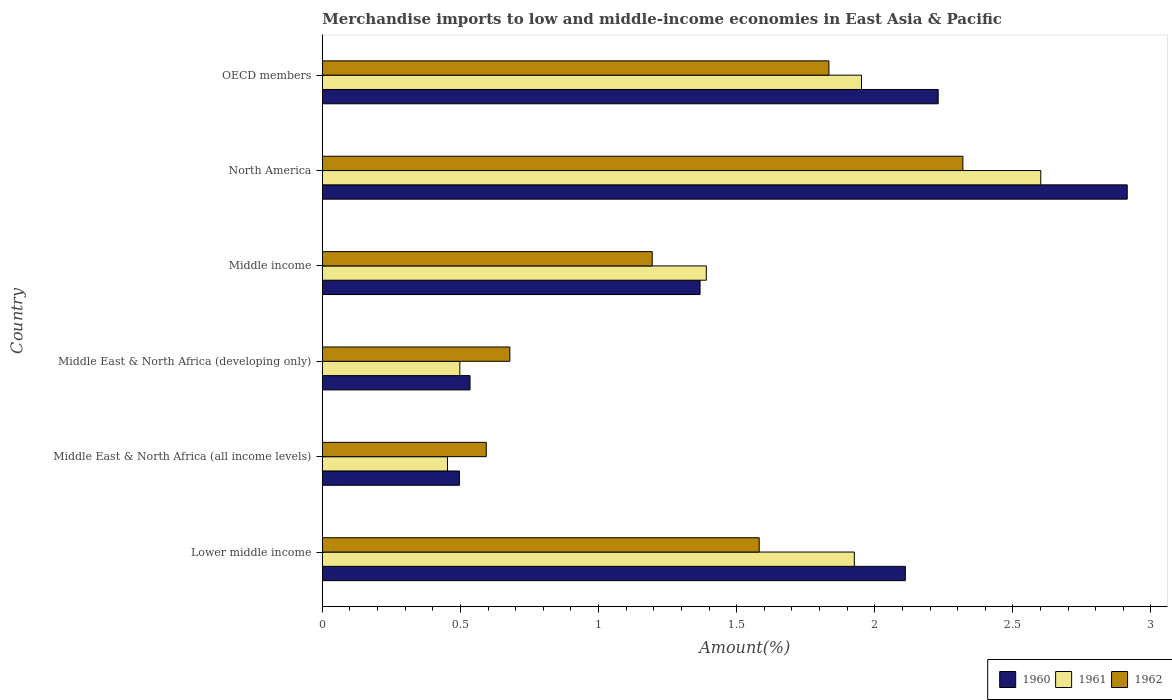How many different coloured bars are there?
Give a very brief answer. 3. How many groups of bars are there?
Your answer should be compact. 6. How many bars are there on the 3rd tick from the top?
Make the answer very short. 3. How many bars are there on the 5th tick from the bottom?
Keep it short and to the point. 3. What is the label of the 4th group of bars from the top?
Your answer should be compact. Middle East & North Africa (developing only). What is the percentage of amount earned from merchandise imports in 1962 in North America?
Provide a short and direct response. 2.32. Across all countries, what is the maximum percentage of amount earned from merchandise imports in 1962?
Provide a succinct answer. 2.32. Across all countries, what is the minimum percentage of amount earned from merchandise imports in 1962?
Offer a terse response. 0.59. In which country was the percentage of amount earned from merchandise imports in 1961 minimum?
Your answer should be compact. Middle East & North Africa (all income levels). What is the total percentage of amount earned from merchandise imports in 1962 in the graph?
Offer a very short reply. 8.2. What is the difference between the percentage of amount earned from merchandise imports in 1962 in North America and that in OECD members?
Ensure brevity in your answer.  0.48. What is the difference between the percentage of amount earned from merchandise imports in 1962 in Middle East & North Africa (developing only) and the percentage of amount earned from merchandise imports in 1960 in OECD members?
Provide a short and direct response. -1.55. What is the average percentage of amount earned from merchandise imports in 1961 per country?
Offer a terse response. 1.47. What is the difference between the percentage of amount earned from merchandise imports in 1961 and percentage of amount earned from merchandise imports in 1962 in North America?
Make the answer very short. 0.28. What is the ratio of the percentage of amount earned from merchandise imports in 1960 in Middle income to that in North America?
Your answer should be very brief. 0.47. Is the difference between the percentage of amount earned from merchandise imports in 1961 in Middle income and OECD members greater than the difference between the percentage of amount earned from merchandise imports in 1962 in Middle income and OECD members?
Offer a very short reply. Yes. What is the difference between the highest and the second highest percentage of amount earned from merchandise imports in 1960?
Offer a terse response. 0.68. What is the difference between the highest and the lowest percentage of amount earned from merchandise imports in 1960?
Your response must be concise. 2.42. In how many countries, is the percentage of amount earned from merchandise imports in 1960 greater than the average percentage of amount earned from merchandise imports in 1960 taken over all countries?
Make the answer very short. 3. Is the sum of the percentage of amount earned from merchandise imports in 1962 in Middle East & North Africa (all income levels) and Middle income greater than the maximum percentage of amount earned from merchandise imports in 1961 across all countries?
Your answer should be very brief. No. How many bars are there?
Provide a short and direct response. 18. Are all the bars in the graph horizontal?
Offer a terse response. Yes. Are the values on the major ticks of X-axis written in scientific E-notation?
Offer a very short reply. No. Does the graph contain any zero values?
Ensure brevity in your answer.  No. How many legend labels are there?
Keep it short and to the point. 3. What is the title of the graph?
Give a very brief answer. Merchandise imports to low and middle-income economies in East Asia & Pacific. What is the label or title of the X-axis?
Make the answer very short. Amount(%). What is the Amount(%) of 1960 in Lower middle income?
Your answer should be very brief. 2.11. What is the Amount(%) of 1961 in Lower middle income?
Provide a succinct answer. 1.93. What is the Amount(%) of 1962 in Lower middle income?
Give a very brief answer. 1.58. What is the Amount(%) of 1960 in Middle East & North Africa (all income levels)?
Your answer should be compact. 0.5. What is the Amount(%) of 1961 in Middle East & North Africa (all income levels)?
Your answer should be compact. 0.45. What is the Amount(%) of 1962 in Middle East & North Africa (all income levels)?
Provide a short and direct response. 0.59. What is the Amount(%) of 1960 in Middle East & North Africa (developing only)?
Offer a terse response. 0.53. What is the Amount(%) of 1961 in Middle East & North Africa (developing only)?
Provide a short and direct response. 0.5. What is the Amount(%) in 1962 in Middle East & North Africa (developing only)?
Offer a terse response. 0.68. What is the Amount(%) in 1960 in Middle income?
Provide a short and direct response. 1.37. What is the Amount(%) in 1961 in Middle income?
Provide a short and direct response. 1.39. What is the Amount(%) of 1962 in Middle income?
Make the answer very short. 1.19. What is the Amount(%) in 1960 in North America?
Make the answer very short. 2.91. What is the Amount(%) of 1961 in North America?
Your response must be concise. 2.6. What is the Amount(%) of 1962 in North America?
Your response must be concise. 2.32. What is the Amount(%) in 1960 in OECD members?
Provide a short and direct response. 2.23. What is the Amount(%) in 1961 in OECD members?
Offer a terse response. 1.95. What is the Amount(%) in 1962 in OECD members?
Provide a short and direct response. 1.83. Across all countries, what is the maximum Amount(%) in 1960?
Keep it short and to the point. 2.91. Across all countries, what is the maximum Amount(%) in 1961?
Offer a very short reply. 2.6. Across all countries, what is the maximum Amount(%) in 1962?
Your answer should be very brief. 2.32. Across all countries, what is the minimum Amount(%) in 1960?
Your answer should be very brief. 0.5. Across all countries, what is the minimum Amount(%) in 1961?
Your answer should be very brief. 0.45. Across all countries, what is the minimum Amount(%) of 1962?
Your answer should be very brief. 0.59. What is the total Amount(%) of 1960 in the graph?
Ensure brevity in your answer.  9.65. What is the total Amount(%) of 1961 in the graph?
Make the answer very short. 8.82. What is the total Amount(%) of 1962 in the graph?
Give a very brief answer. 8.2. What is the difference between the Amount(%) in 1960 in Lower middle income and that in Middle East & North Africa (all income levels)?
Offer a very short reply. 1.61. What is the difference between the Amount(%) in 1961 in Lower middle income and that in Middle East & North Africa (all income levels)?
Provide a short and direct response. 1.47. What is the difference between the Amount(%) in 1962 in Lower middle income and that in Middle East & North Africa (all income levels)?
Ensure brevity in your answer.  0.99. What is the difference between the Amount(%) of 1960 in Lower middle income and that in Middle East & North Africa (developing only)?
Your answer should be very brief. 1.58. What is the difference between the Amount(%) in 1961 in Lower middle income and that in Middle East & North Africa (developing only)?
Provide a succinct answer. 1.43. What is the difference between the Amount(%) of 1962 in Lower middle income and that in Middle East & North Africa (developing only)?
Keep it short and to the point. 0.9. What is the difference between the Amount(%) in 1960 in Lower middle income and that in Middle income?
Offer a terse response. 0.74. What is the difference between the Amount(%) of 1961 in Lower middle income and that in Middle income?
Offer a very short reply. 0.54. What is the difference between the Amount(%) of 1962 in Lower middle income and that in Middle income?
Ensure brevity in your answer.  0.39. What is the difference between the Amount(%) of 1960 in Lower middle income and that in North America?
Offer a terse response. -0.8. What is the difference between the Amount(%) of 1961 in Lower middle income and that in North America?
Give a very brief answer. -0.67. What is the difference between the Amount(%) in 1962 in Lower middle income and that in North America?
Provide a short and direct response. -0.74. What is the difference between the Amount(%) of 1960 in Lower middle income and that in OECD members?
Provide a short and direct response. -0.12. What is the difference between the Amount(%) of 1961 in Lower middle income and that in OECD members?
Your answer should be very brief. -0.03. What is the difference between the Amount(%) of 1962 in Lower middle income and that in OECD members?
Give a very brief answer. -0.25. What is the difference between the Amount(%) of 1960 in Middle East & North Africa (all income levels) and that in Middle East & North Africa (developing only)?
Your answer should be compact. -0.04. What is the difference between the Amount(%) of 1961 in Middle East & North Africa (all income levels) and that in Middle East & North Africa (developing only)?
Ensure brevity in your answer.  -0.04. What is the difference between the Amount(%) in 1962 in Middle East & North Africa (all income levels) and that in Middle East & North Africa (developing only)?
Provide a short and direct response. -0.09. What is the difference between the Amount(%) of 1960 in Middle East & North Africa (all income levels) and that in Middle income?
Keep it short and to the point. -0.87. What is the difference between the Amount(%) of 1961 in Middle East & North Africa (all income levels) and that in Middle income?
Offer a terse response. -0.94. What is the difference between the Amount(%) of 1962 in Middle East & North Africa (all income levels) and that in Middle income?
Provide a short and direct response. -0.6. What is the difference between the Amount(%) in 1960 in Middle East & North Africa (all income levels) and that in North America?
Your answer should be compact. -2.42. What is the difference between the Amount(%) in 1961 in Middle East & North Africa (all income levels) and that in North America?
Your answer should be very brief. -2.15. What is the difference between the Amount(%) in 1962 in Middle East & North Africa (all income levels) and that in North America?
Make the answer very short. -1.73. What is the difference between the Amount(%) of 1960 in Middle East & North Africa (all income levels) and that in OECD members?
Your answer should be compact. -1.73. What is the difference between the Amount(%) of 1961 in Middle East & North Africa (all income levels) and that in OECD members?
Your answer should be compact. -1.5. What is the difference between the Amount(%) of 1962 in Middle East & North Africa (all income levels) and that in OECD members?
Keep it short and to the point. -1.24. What is the difference between the Amount(%) of 1960 in Middle East & North Africa (developing only) and that in Middle income?
Provide a short and direct response. -0.83. What is the difference between the Amount(%) in 1961 in Middle East & North Africa (developing only) and that in Middle income?
Provide a short and direct response. -0.89. What is the difference between the Amount(%) of 1962 in Middle East & North Africa (developing only) and that in Middle income?
Offer a terse response. -0.52. What is the difference between the Amount(%) in 1960 in Middle East & North Africa (developing only) and that in North America?
Your answer should be very brief. -2.38. What is the difference between the Amount(%) of 1961 in Middle East & North Africa (developing only) and that in North America?
Make the answer very short. -2.1. What is the difference between the Amount(%) in 1962 in Middle East & North Africa (developing only) and that in North America?
Provide a short and direct response. -1.64. What is the difference between the Amount(%) in 1960 in Middle East & North Africa (developing only) and that in OECD members?
Your answer should be very brief. -1.69. What is the difference between the Amount(%) in 1961 in Middle East & North Africa (developing only) and that in OECD members?
Your response must be concise. -1.45. What is the difference between the Amount(%) of 1962 in Middle East & North Africa (developing only) and that in OECD members?
Your answer should be very brief. -1.16. What is the difference between the Amount(%) in 1960 in Middle income and that in North America?
Your answer should be very brief. -1.55. What is the difference between the Amount(%) of 1961 in Middle income and that in North America?
Your answer should be compact. -1.21. What is the difference between the Amount(%) in 1962 in Middle income and that in North America?
Your answer should be very brief. -1.12. What is the difference between the Amount(%) of 1960 in Middle income and that in OECD members?
Keep it short and to the point. -0.86. What is the difference between the Amount(%) in 1961 in Middle income and that in OECD members?
Provide a succinct answer. -0.56. What is the difference between the Amount(%) in 1962 in Middle income and that in OECD members?
Your answer should be compact. -0.64. What is the difference between the Amount(%) of 1960 in North America and that in OECD members?
Offer a terse response. 0.68. What is the difference between the Amount(%) of 1961 in North America and that in OECD members?
Your response must be concise. 0.65. What is the difference between the Amount(%) in 1962 in North America and that in OECD members?
Provide a short and direct response. 0.48. What is the difference between the Amount(%) in 1960 in Lower middle income and the Amount(%) in 1961 in Middle East & North Africa (all income levels)?
Give a very brief answer. 1.66. What is the difference between the Amount(%) of 1960 in Lower middle income and the Amount(%) of 1962 in Middle East & North Africa (all income levels)?
Your response must be concise. 1.52. What is the difference between the Amount(%) in 1961 in Lower middle income and the Amount(%) in 1962 in Middle East & North Africa (all income levels)?
Ensure brevity in your answer.  1.33. What is the difference between the Amount(%) in 1960 in Lower middle income and the Amount(%) in 1961 in Middle East & North Africa (developing only)?
Keep it short and to the point. 1.61. What is the difference between the Amount(%) in 1960 in Lower middle income and the Amount(%) in 1962 in Middle East & North Africa (developing only)?
Offer a very short reply. 1.43. What is the difference between the Amount(%) in 1961 in Lower middle income and the Amount(%) in 1962 in Middle East & North Africa (developing only)?
Offer a terse response. 1.25. What is the difference between the Amount(%) of 1960 in Lower middle income and the Amount(%) of 1961 in Middle income?
Offer a very short reply. 0.72. What is the difference between the Amount(%) in 1960 in Lower middle income and the Amount(%) in 1962 in Middle income?
Your answer should be very brief. 0.92. What is the difference between the Amount(%) in 1961 in Lower middle income and the Amount(%) in 1962 in Middle income?
Your answer should be very brief. 0.73. What is the difference between the Amount(%) in 1960 in Lower middle income and the Amount(%) in 1961 in North America?
Your answer should be very brief. -0.49. What is the difference between the Amount(%) in 1960 in Lower middle income and the Amount(%) in 1962 in North America?
Your response must be concise. -0.21. What is the difference between the Amount(%) in 1961 in Lower middle income and the Amount(%) in 1962 in North America?
Offer a terse response. -0.39. What is the difference between the Amount(%) of 1960 in Lower middle income and the Amount(%) of 1961 in OECD members?
Keep it short and to the point. 0.16. What is the difference between the Amount(%) of 1960 in Lower middle income and the Amount(%) of 1962 in OECD members?
Provide a succinct answer. 0.28. What is the difference between the Amount(%) in 1961 in Lower middle income and the Amount(%) in 1962 in OECD members?
Offer a terse response. 0.09. What is the difference between the Amount(%) of 1960 in Middle East & North Africa (all income levels) and the Amount(%) of 1961 in Middle East & North Africa (developing only)?
Offer a terse response. -0. What is the difference between the Amount(%) of 1960 in Middle East & North Africa (all income levels) and the Amount(%) of 1962 in Middle East & North Africa (developing only)?
Provide a short and direct response. -0.18. What is the difference between the Amount(%) in 1961 in Middle East & North Africa (all income levels) and the Amount(%) in 1962 in Middle East & North Africa (developing only)?
Provide a succinct answer. -0.23. What is the difference between the Amount(%) in 1960 in Middle East & North Africa (all income levels) and the Amount(%) in 1961 in Middle income?
Offer a terse response. -0.89. What is the difference between the Amount(%) in 1960 in Middle East & North Africa (all income levels) and the Amount(%) in 1962 in Middle income?
Ensure brevity in your answer.  -0.7. What is the difference between the Amount(%) in 1961 in Middle East & North Africa (all income levels) and the Amount(%) in 1962 in Middle income?
Your response must be concise. -0.74. What is the difference between the Amount(%) of 1960 in Middle East & North Africa (all income levels) and the Amount(%) of 1961 in North America?
Give a very brief answer. -2.1. What is the difference between the Amount(%) of 1960 in Middle East & North Africa (all income levels) and the Amount(%) of 1962 in North America?
Make the answer very short. -1.82. What is the difference between the Amount(%) of 1961 in Middle East & North Africa (all income levels) and the Amount(%) of 1962 in North America?
Offer a very short reply. -1.87. What is the difference between the Amount(%) of 1960 in Middle East & North Africa (all income levels) and the Amount(%) of 1961 in OECD members?
Provide a short and direct response. -1.46. What is the difference between the Amount(%) in 1960 in Middle East & North Africa (all income levels) and the Amount(%) in 1962 in OECD members?
Your response must be concise. -1.34. What is the difference between the Amount(%) in 1961 in Middle East & North Africa (all income levels) and the Amount(%) in 1962 in OECD members?
Your answer should be compact. -1.38. What is the difference between the Amount(%) in 1960 in Middle East & North Africa (developing only) and the Amount(%) in 1961 in Middle income?
Ensure brevity in your answer.  -0.86. What is the difference between the Amount(%) of 1960 in Middle East & North Africa (developing only) and the Amount(%) of 1962 in Middle income?
Provide a succinct answer. -0.66. What is the difference between the Amount(%) in 1961 in Middle East & North Africa (developing only) and the Amount(%) in 1962 in Middle income?
Provide a succinct answer. -0.7. What is the difference between the Amount(%) in 1960 in Middle East & North Africa (developing only) and the Amount(%) in 1961 in North America?
Your response must be concise. -2.07. What is the difference between the Amount(%) of 1960 in Middle East & North Africa (developing only) and the Amount(%) of 1962 in North America?
Your answer should be compact. -1.78. What is the difference between the Amount(%) of 1961 in Middle East & North Africa (developing only) and the Amount(%) of 1962 in North America?
Make the answer very short. -1.82. What is the difference between the Amount(%) of 1960 in Middle East & North Africa (developing only) and the Amount(%) of 1961 in OECD members?
Your response must be concise. -1.42. What is the difference between the Amount(%) in 1960 in Middle East & North Africa (developing only) and the Amount(%) in 1962 in OECD members?
Your answer should be very brief. -1.3. What is the difference between the Amount(%) of 1961 in Middle East & North Africa (developing only) and the Amount(%) of 1962 in OECD members?
Your answer should be compact. -1.34. What is the difference between the Amount(%) in 1960 in Middle income and the Amount(%) in 1961 in North America?
Your response must be concise. -1.23. What is the difference between the Amount(%) in 1960 in Middle income and the Amount(%) in 1962 in North America?
Your answer should be compact. -0.95. What is the difference between the Amount(%) in 1961 in Middle income and the Amount(%) in 1962 in North America?
Make the answer very short. -0.93. What is the difference between the Amount(%) in 1960 in Middle income and the Amount(%) in 1961 in OECD members?
Your answer should be very brief. -0.58. What is the difference between the Amount(%) of 1960 in Middle income and the Amount(%) of 1962 in OECD members?
Offer a very short reply. -0.47. What is the difference between the Amount(%) in 1961 in Middle income and the Amount(%) in 1962 in OECD members?
Offer a terse response. -0.44. What is the difference between the Amount(%) in 1960 in North America and the Amount(%) in 1961 in OECD members?
Give a very brief answer. 0.96. What is the difference between the Amount(%) in 1960 in North America and the Amount(%) in 1962 in OECD members?
Ensure brevity in your answer.  1.08. What is the difference between the Amount(%) in 1961 in North America and the Amount(%) in 1962 in OECD members?
Your answer should be compact. 0.77. What is the average Amount(%) in 1960 per country?
Your response must be concise. 1.61. What is the average Amount(%) in 1961 per country?
Offer a terse response. 1.47. What is the average Amount(%) in 1962 per country?
Your answer should be very brief. 1.37. What is the difference between the Amount(%) in 1960 and Amount(%) in 1961 in Lower middle income?
Provide a short and direct response. 0.18. What is the difference between the Amount(%) of 1960 and Amount(%) of 1962 in Lower middle income?
Your answer should be very brief. 0.53. What is the difference between the Amount(%) in 1961 and Amount(%) in 1962 in Lower middle income?
Give a very brief answer. 0.34. What is the difference between the Amount(%) in 1960 and Amount(%) in 1961 in Middle East & North Africa (all income levels)?
Offer a terse response. 0.04. What is the difference between the Amount(%) in 1960 and Amount(%) in 1962 in Middle East & North Africa (all income levels)?
Your answer should be very brief. -0.1. What is the difference between the Amount(%) of 1961 and Amount(%) of 1962 in Middle East & North Africa (all income levels)?
Give a very brief answer. -0.14. What is the difference between the Amount(%) in 1960 and Amount(%) in 1961 in Middle East & North Africa (developing only)?
Give a very brief answer. 0.04. What is the difference between the Amount(%) of 1960 and Amount(%) of 1962 in Middle East & North Africa (developing only)?
Provide a short and direct response. -0.14. What is the difference between the Amount(%) in 1961 and Amount(%) in 1962 in Middle East & North Africa (developing only)?
Your response must be concise. -0.18. What is the difference between the Amount(%) in 1960 and Amount(%) in 1961 in Middle income?
Your answer should be very brief. -0.02. What is the difference between the Amount(%) in 1960 and Amount(%) in 1962 in Middle income?
Your answer should be very brief. 0.17. What is the difference between the Amount(%) in 1961 and Amount(%) in 1962 in Middle income?
Make the answer very short. 0.2. What is the difference between the Amount(%) of 1960 and Amount(%) of 1961 in North America?
Ensure brevity in your answer.  0.31. What is the difference between the Amount(%) in 1960 and Amount(%) in 1962 in North America?
Make the answer very short. 0.6. What is the difference between the Amount(%) in 1961 and Amount(%) in 1962 in North America?
Provide a succinct answer. 0.28. What is the difference between the Amount(%) of 1960 and Amount(%) of 1961 in OECD members?
Offer a very short reply. 0.28. What is the difference between the Amount(%) in 1960 and Amount(%) in 1962 in OECD members?
Offer a terse response. 0.4. What is the difference between the Amount(%) of 1961 and Amount(%) of 1962 in OECD members?
Your answer should be very brief. 0.12. What is the ratio of the Amount(%) in 1960 in Lower middle income to that in Middle East & North Africa (all income levels)?
Your answer should be very brief. 4.25. What is the ratio of the Amount(%) in 1961 in Lower middle income to that in Middle East & North Africa (all income levels)?
Your answer should be compact. 4.25. What is the ratio of the Amount(%) in 1962 in Lower middle income to that in Middle East & North Africa (all income levels)?
Make the answer very short. 2.67. What is the ratio of the Amount(%) of 1960 in Lower middle income to that in Middle East & North Africa (developing only)?
Offer a very short reply. 3.95. What is the ratio of the Amount(%) of 1961 in Lower middle income to that in Middle East & North Africa (developing only)?
Provide a succinct answer. 3.87. What is the ratio of the Amount(%) in 1962 in Lower middle income to that in Middle East & North Africa (developing only)?
Your answer should be compact. 2.33. What is the ratio of the Amount(%) of 1960 in Lower middle income to that in Middle income?
Offer a very short reply. 1.54. What is the ratio of the Amount(%) in 1961 in Lower middle income to that in Middle income?
Provide a short and direct response. 1.39. What is the ratio of the Amount(%) in 1962 in Lower middle income to that in Middle income?
Your response must be concise. 1.32. What is the ratio of the Amount(%) in 1960 in Lower middle income to that in North America?
Provide a succinct answer. 0.72. What is the ratio of the Amount(%) in 1961 in Lower middle income to that in North America?
Your answer should be very brief. 0.74. What is the ratio of the Amount(%) of 1962 in Lower middle income to that in North America?
Make the answer very short. 0.68. What is the ratio of the Amount(%) in 1960 in Lower middle income to that in OECD members?
Keep it short and to the point. 0.95. What is the ratio of the Amount(%) in 1961 in Lower middle income to that in OECD members?
Give a very brief answer. 0.99. What is the ratio of the Amount(%) in 1962 in Lower middle income to that in OECD members?
Provide a short and direct response. 0.86. What is the ratio of the Amount(%) in 1960 in Middle East & North Africa (all income levels) to that in Middle East & North Africa (developing only)?
Give a very brief answer. 0.93. What is the ratio of the Amount(%) in 1961 in Middle East & North Africa (all income levels) to that in Middle East & North Africa (developing only)?
Give a very brief answer. 0.91. What is the ratio of the Amount(%) of 1962 in Middle East & North Africa (all income levels) to that in Middle East & North Africa (developing only)?
Give a very brief answer. 0.87. What is the ratio of the Amount(%) in 1960 in Middle East & North Africa (all income levels) to that in Middle income?
Offer a terse response. 0.36. What is the ratio of the Amount(%) in 1961 in Middle East & North Africa (all income levels) to that in Middle income?
Give a very brief answer. 0.33. What is the ratio of the Amount(%) of 1962 in Middle East & North Africa (all income levels) to that in Middle income?
Your answer should be compact. 0.5. What is the ratio of the Amount(%) in 1960 in Middle East & North Africa (all income levels) to that in North America?
Ensure brevity in your answer.  0.17. What is the ratio of the Amount(%) in 1961 in Middle East & North Africa (all income levels) to that in North America?
Your answer should be compact. 0.17. What is the ratio of the Amount(%) in 1962 in Middle East & North Africa (all income levels) to that in North America?
Provide a succinct answer. 0.26. What is the ratio of the Amount(%) of 1960 in Middle East & North Africa (all income levels) to that in OECD members?
Provide a short and direct response. 0.22. What is the ratio of the Amount(%) in 1961 in Middle East & North Africa (all income levels) to that in OECD members?
Make the answer very short. 0.23. What is the ratio of the Amount(%) of 1962 in Middle East & North Africa (all income levels) to that in OECD members?
Make the answer very short. 0.32. What is the ratio of the Amount(%) in 1960 in Middle East & North Africa (developing only) to that in Middle income?
Provide a short and direct response. 0.39. What is the ratio of the Amount(%) of 1961 in Middle East & North Africa (developing only) to that in Middle income?
Your response must be concise. 0.36. What is the ratio of the Amount(%) of 1962 in Middle East & North Africa (developing only) to that in Middle income?
Ensure brevity in your answer.  0.57. What is the ratio of the Amount(%) of 1960 in Middle East & North Africa (developing only) to that in North America?
Provide a succinct answer. 0.18. What is the ratio of the Amount(%) in 1961 in Middle East & North Africa (developing only) to that in North America?
Offer a terse response. 0.19. What is the ratio of the Amount(%) in 1962 in Middle East & North Africa (developing only) to that in North America?
Provide a short and direct response. 0.29. What is the ratio of the Amount(%) in 1960 in Middle East & North Africa (developing only) to that in OECD members?
Your response must be concise. 0.24. What is the ratio of the Amount(%) in 1961 in Middle East & North Africa (developing only) to that in OECD members?
Ensure brevity in your answer.  0.26. What is the ratio of the Amount(%) of 1962 in Middle East & North Africa (developing only) to that in OECD members?
Provide a short and direct response. 0.37. What is the ratio of the Amount(%) in 1960 in Middle income to that in North America?
Keep it short and to the point. 0.47. What is the ratio of the Amount(%) in 1961 in Middle income to that in North America?
Keep it short and to the point. 0.53. What is the ratio of the Amount(%) of 1962 in Middle income to that in North America?
Offer a very short reply. 0.52. What is the ratio of the Amount(%) of 1960 in Middle income to that in OECD members?
Give a very brief answer. 0.61. What is the ratio of the Amount(%) of 1961 in Middle income to that in OECD members?
Give a very brief answer. 0.71. What is the ratio of the Amount(%) in 1962 in Middle income to that in OECD members?
Offer a terse response. 0.65. What is the ratio of the Amount(%) in 1960 in North America to that in OECD members?
Your response must be concise. 1.31. What is the ratio of the Amount(%) of 1961 in North America to that in OECD members?
Your answer should be compact. 1.33. What is the ratio of the Amount(%) in 1962 in North America to that in OECD members?
Ensure brevity in your answer.  1.26. What is the difference between the highest and the second highest Amount(%) of 1960?
Your answer should be very brief. 0.68. What is the difference between the highest and the second highest Amount(%) of 1961?
Offer a terse response. 0.65. What is the difference between the highest and the second highest Amount(%) of 1962?
Your response must be concise. 0.48. What is the difference between the highest and the lowest Amount(%) of 1960?
Your response must be concise. 2.42. What is the difference between the highest and the lowest Amount(%) of 1961?
Offer a terse response. 2.15. What is the difference between the highest and the lowest Amount(%) in 1962?
Give a very brief answer. 1.73. 